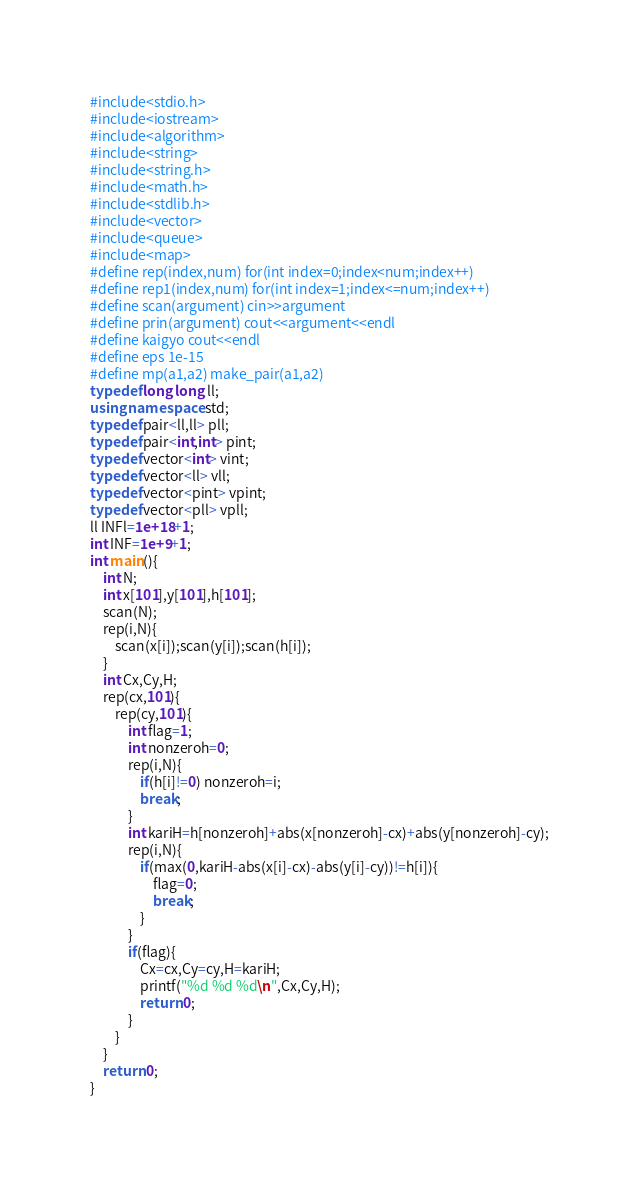Convert code to text. <code><loc_0><loc_0><loc_500><loc_500><_C++_>#include<stdio.h>
#include<iostream>
#include<algorithm>
#include<string>
#include<string.h>
#include<math.h>
#include<stdlib.h>
#include<vector>
#include<queue>
#include<map>
#define rep(index,num) for(int index=0;index<num;index++)
#define rep1(index,num) for(int index=1;index<=num;index++)
#define scan(argument) cin>>argument
#define prin(argument) cout<<argument<<endl
#define kaigyo cout<<endl
#define eps 1e-15
#define mp(a1,a2) make_pair(a1,a2)
typedef long long ll;
using namespace std;
typedef pair<ll,ll> pll;
typedef pair<int,int> pint;
typedef vector<int> vint;
typedef vector<ll> vll;
typedef vector<pint> vpint;
typedef vector<pll> vpll;
ll INFl=1e+18+1;
int INF=1e+9+1;
int main(){
	int N;
	int x[101],y[101],h[101];
	scan(N);
	rep(i,N){
		scan(x[i]);scan(y[i]);scan(h[i]);
	}
	int Cx,Cy,H;
	rep(cx,101){
		rep(cy,101){
			int flag=1;
			int nonzeroh=0;
			rep(i,N){
				if(h[i]!=0) nonzeroh=i;
				break;
			}
			int kariH=h[nonzeroh]+abs(x[nonzeroh]-cx)+abs(y[nonzeroh]-cy);
			rep(i,N){
				if(max(0,kariH-abs(x[i]-cx)-abs(y[i]-cy))!=h[i]){
					flag=0;
					break;
				}
			}
			if(flag){
				Cx=cx,Cy=cy,H=kariH;
				printf("%d %d %d\n",Cx,Cy,H);
				return 0;
			}
		}
	}
	return 0;
}
</code> 